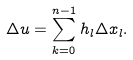<formula> <loc_0><loc_0><loc_500><loc_500>\Delta u = \sum _ { k = 0 } ^ { n - 1 } h _ { l } \Delta x _ { l } .</formula> 